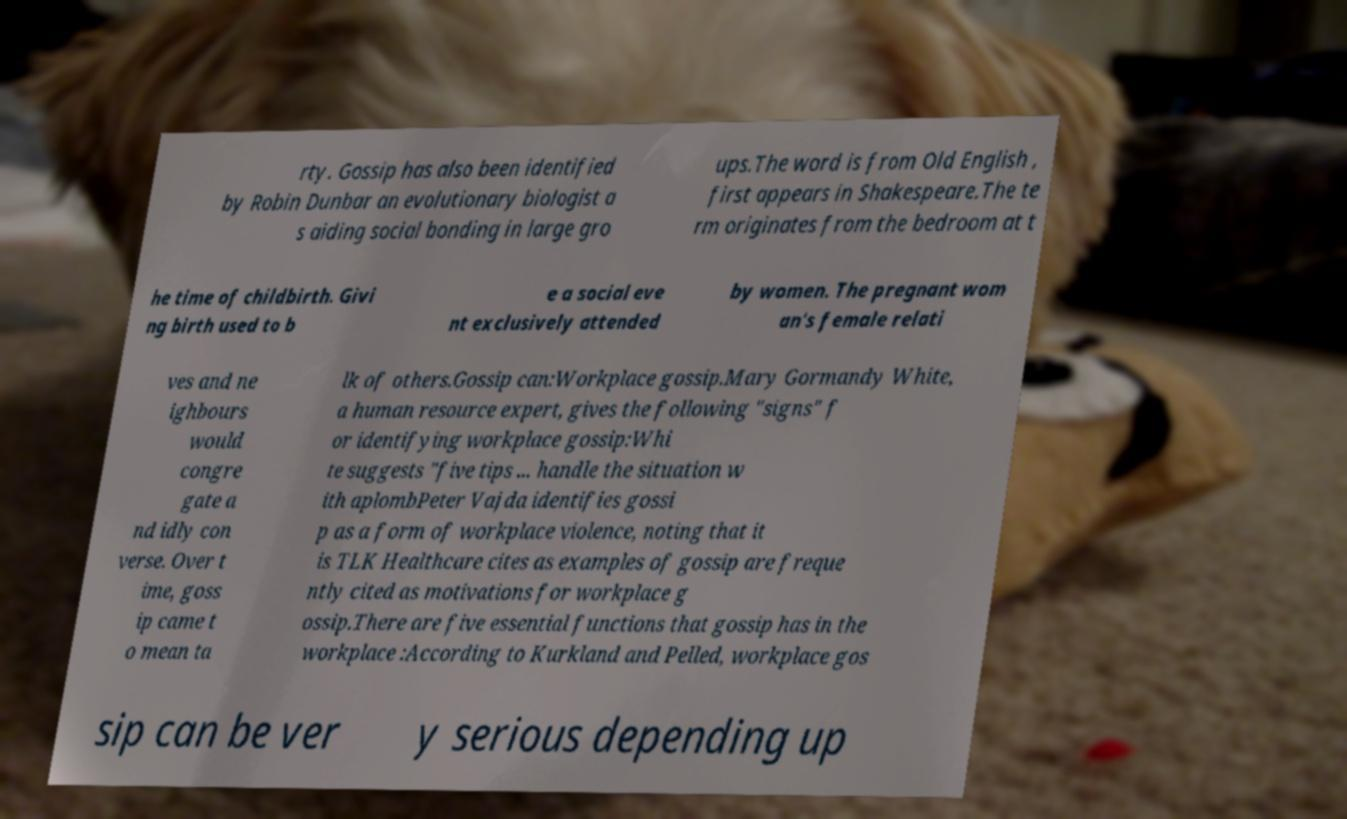Can you read and provide the text displayed in the image?This photo seems to have some interesting text. Can you extract and type it out for me? rty. Gossip has also been identified by Robin Dunbar an evolutionary biologist a s aiding social bonding in large gro ups.The word is from Old English , first appears in Shakespeare.The te rm originates from the bedroom at t he time of childbirth. Givi ng birth used to b e a social eve nt exclusively attended by women. The pregnant wom an's female relati ves and ne ighbours would congre gate a nd idly con verse. Over t ime, goss ip came t o mean ta lk of others.Gossip can:Workplace gossip.Mary Gormandy White, a human resource expert, gives the following "signs" f or identifying workplace gossip:Whi te suggests "five tips ... handle the situation w ith aplombPeter Vajda identifies gossi p as a form of workplace violence, noting that it is TLK Healthcare cites as examples of gossip are freque ntly cited as motivations for workplace g ossip.There are five essential functions that gossip has in the workplace :According to Kurkland and Pelled, workplace gos sip can be ver y serious depending up 